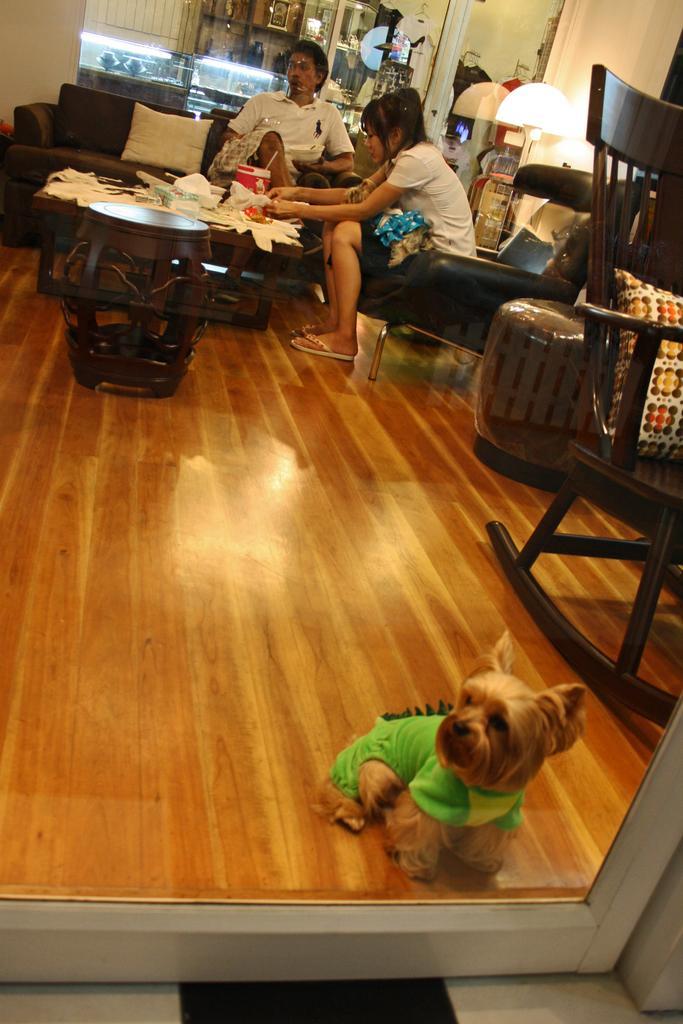Could you give a brief overview of what you see in this image? In this image on the right there is a chair, pillow,light and woman. In the middle, there is a table on that there are many tissues and sofa on that there is a man. At the bottom there is a dog. 